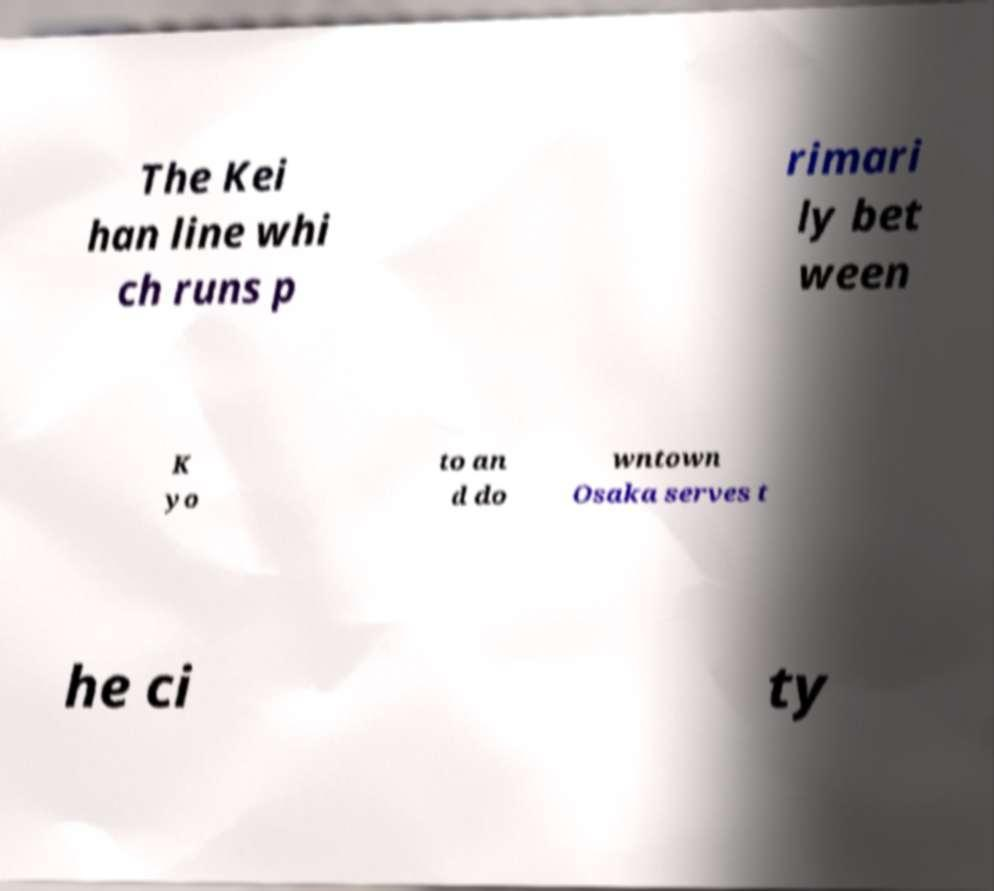Could you assist in decoding the text presented in this image and type it out clearly? The Kei han line whi ch runs p rimari ly bet ween K yo to an d do wntown Osaka serves t he ci ty 